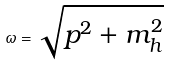Convert formula to latex. <formula><loc_0><loc_0><loc_500><loc_500>\omega = \sqrt { p ^ { 2 } + m _ { h } ^ { 2 } }</formula> 